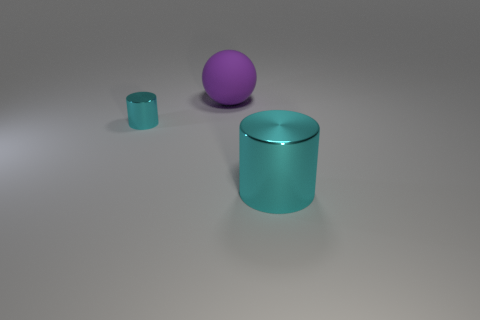Is there a significant difference in the surface texture or material between the cyan objects and the purple sphere? The surface texture of both the cyan objects appears smoother and has a reflective quality, while the large purple sphere seems to have a slightly matte finish, indicating a possible difference in material or the effect of the lighting on their surfaces. 